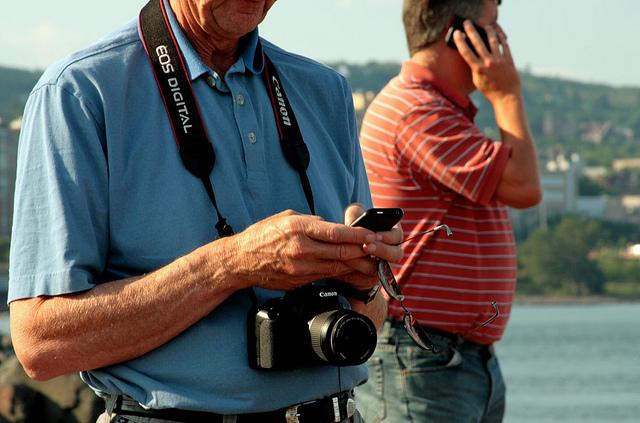Is one of the men a photographer?
Short answer required. Yes. How many men are there?
Answer briefly. 2. What devices are seen?
Write a very short answer. Camera and 2 phones. 